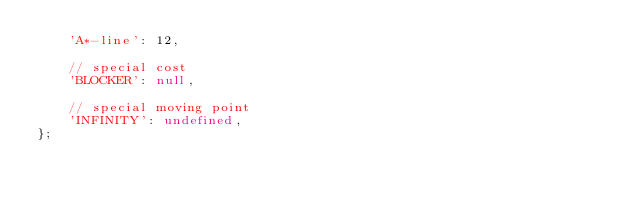<code> <loc_0><loc_0><loc_500><loc_500><_JavaScript_>    'A*-line': 12,

    // special cost
    'BLOCKER': null,

    // special moving point
    'INFINITY': undefined,
};</code> 